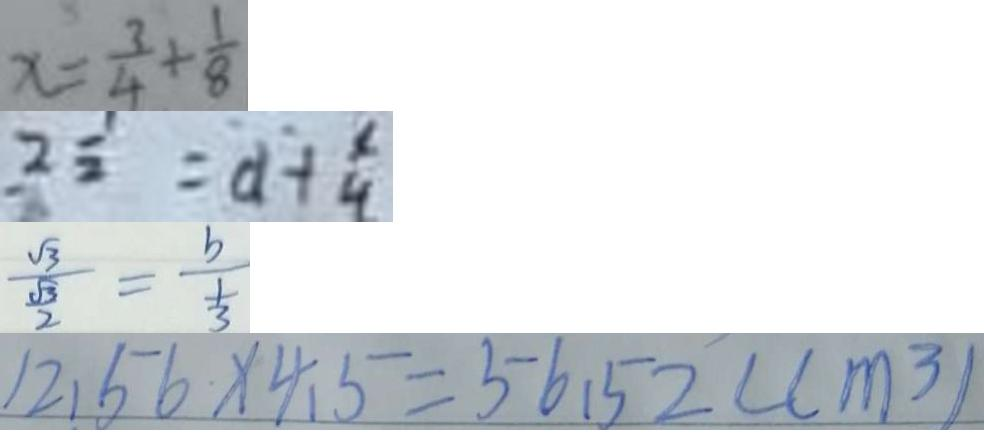<formula> <loc_0><loc_0><loc_500><loc_500>x = \frac { 3 } { 4 } + \frac { 1 } { 8 } 
 2 \frac { 1 } { 2 } = d + \frac { x } { 4 } 
 \frac { \sqrt { 3 } } { \frac { \sqrt { 3 } } { 2 } } = \frac { b } { \frac { 1 } { 3 } } 
 1 2 . 5 6 \times 4 . 5 = 5 6 . 5 2 ( c m ^ { 3 } )</formula> 